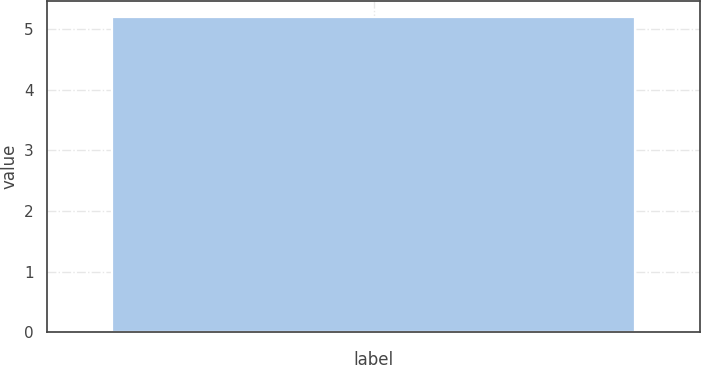Convert chart to OTSL. <chart><loc_0><loc_0><loc_500><loc_500><bar_chart><ecel><nl><fcel>5.2<nl></chart> 